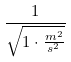Convert formula to latex. <formula><loc_0><loc_0><loc_500><loc_500>\frac { 1 } { \sqrt { 1 \cdot \frac { m ^ { 2 } } { s ^ { 2 } } } }</formula> 